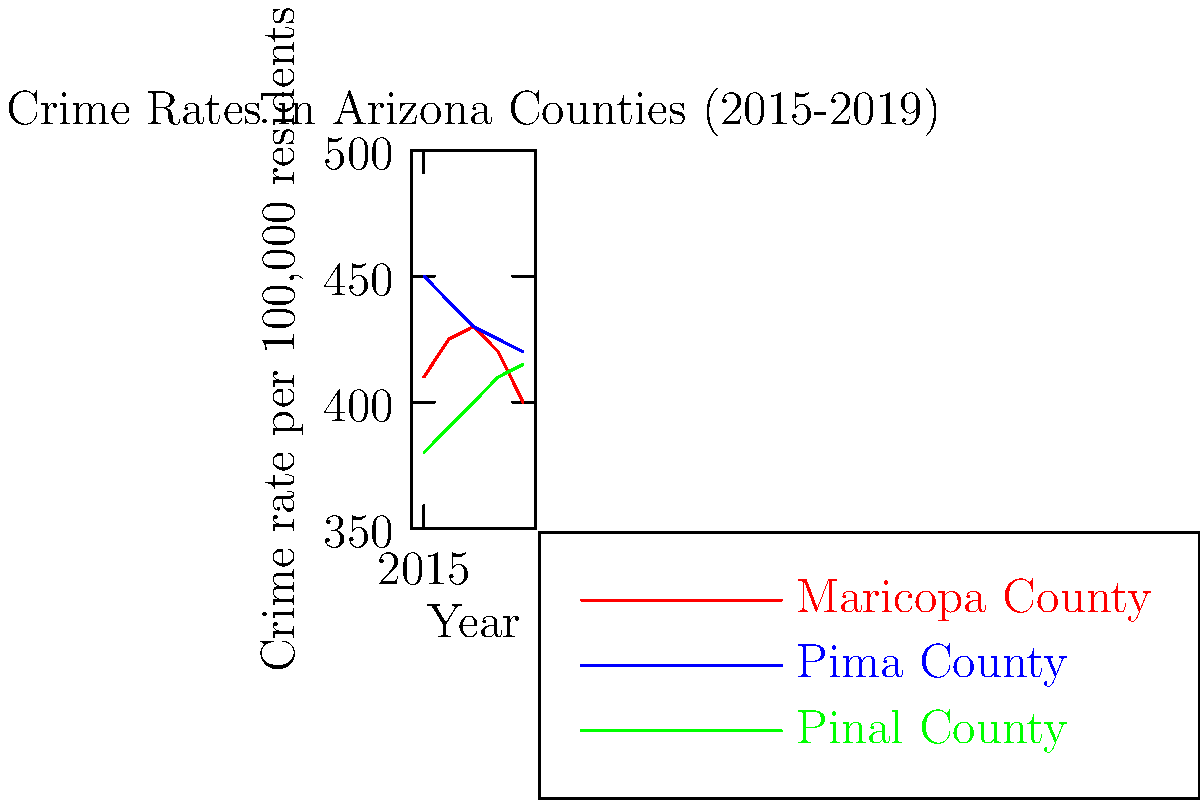As an investigative journalist in Arizona, you're analyzing crime rate trends in three major counties. Based on the line graph showing crime rates per 100,000 residents from 2015 to 2019, which county demonstrates the most consistent downward trend in crime rates, and what might this suggest about local law enforcement strategies? To answer this question, we need to analyze the trends for each county:

1. Maricopa County (red line):
   - Shows fluctuations, increasing from 2015 to 2017, then decreasing from 2017 to 2019
   - Overall trend is not consistently downward

2. Pima County (blue line):
   - Shows a consistent downward trend from 2015 to 2019
   - Decreases steadily each year without any increases

3. Pinal County (green line):
   - Shows a consistent upward trend from 2015 to 2019
   - Increases steadily each year without any decreases

Among these three counties, Pima County demonstrates the most consistent downward trend in crime rates.

This consistent decrease in Pima County's crime rate might suggest:

1. Effective and consistent law enforcement strategies
2. Successful community-based crime prevention programs
3. Improvements in socioeconomic factors that can influence crime rates
4. Better resource allocation and utilization in the criminal justice system

As an investigative journalist, this trend would warrant further investigation into Pima County's specific law enforcement and community strategies that might be contributing to this consistent decrease in crime rates.
Answer: Pima County; suggests effective, consistent law enforcement and crime prevention strategies 